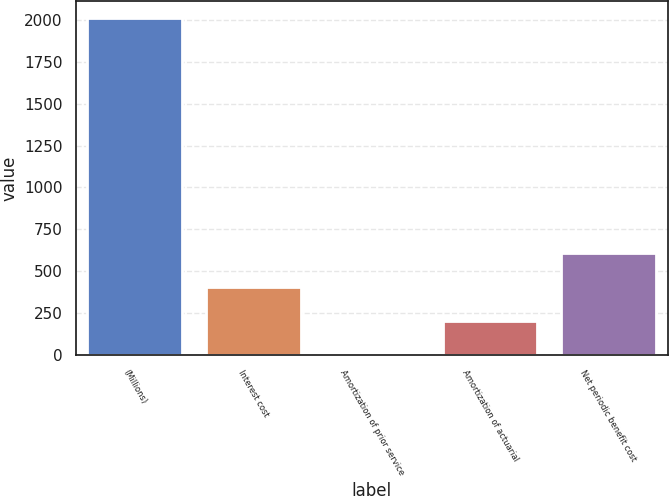<chart> <loc_0><loc_0><loc_500><loc_500><bar_chart><fcel>(Millions)<fcel>Interest cost<fcel>Amortization of prior service<fcel>Amortization of actuarial<fcel>Net periodic benefit cost<nl><fcel>2010<fcel>406<fcel>5<fcel>205.5<fcel>606.5<nl></chart> 